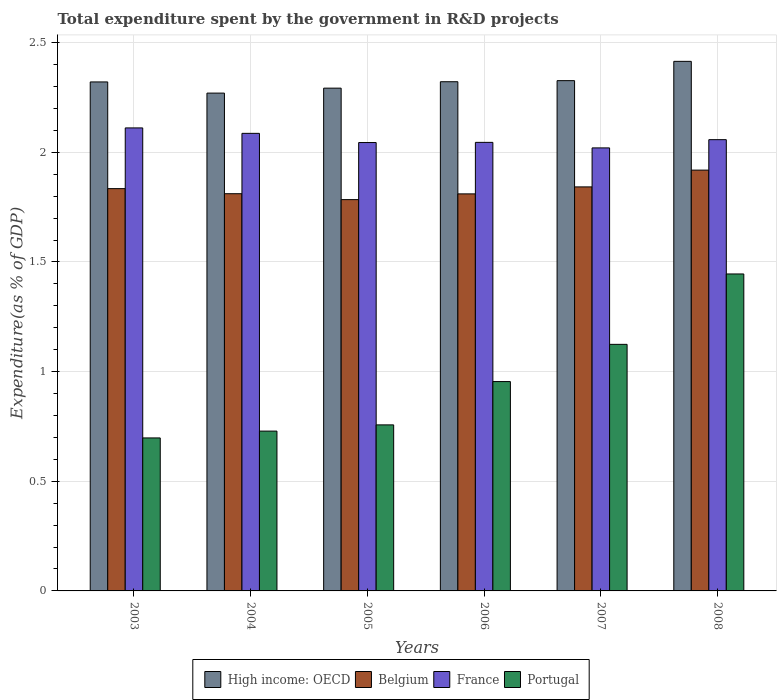How many groups of bars are there?
Offer a very short reply. 6. In how many cases, is the number of bars for a given year not equal to the number of legend labels?
Your answer should be very brief. 0. What is the total expenditure spent by the government in R&D projects in High income: OECD in 2008?
Provide a short and direct response. 2.41. Across all years, what is the maximum total expenditure spent by the government in R&D projects in France?
Your answer should be compact. 2.11. Across all years, what is the minimum total expenditure spent by the government in R&D projects in France?
Your answer should be compact. 2.02. In which year was the total expenditure spent by the government in R&D projects in Portugal minimum?
Offer a very short reply. 2003. What is the total total expenditure spent by the government in R&D projects in Portugal in the graph?
Give a very brief answer. 5.71. What is the difference between the total expenditure spent by the government in R&D projects in Belgium in 2004 and that in 2008?
Provide a succinct answer. -0.11. What is the difference between the total expenditure spent by the government in R&D projects in High income: OECD in 2005 and the total expenditure spent by the government in R&D projects in Belgium in 2003?
Offer a very short reply. 0.46. What is the average total expenditure spent by the government in R&D projects in France per year?
Your answer should be very brief. 2.06. In the year 2003, what is the difference between the total expenditure spent by the government in R&D projects in High income: OECD and total expenditure spent by the government in R&D projects in Belgium?
Keep it short and to the point. 0.49. What is the ratio of the total expenditure spent by the government in R&D projects in France in 2006 to that in 2007?
Keep it short and to the point. 1.01. What is the difference between the highest and the second highest total expenditure spent by the government in R&D projects in France?
Provide a short and direct response. 0.02. What is the difference between the highest and the lowest total expenditure spent by the government in R&D projects in High income: OECD?
Provide a short and direct response. 0.14. Is the sum of the total expenditure spent by the government in R&D projects in Portugal in 2006 and 2008 greater than the maximum total expenditure spent by the government in R&D projects in High income: OECD across all years?
Your answer should be compact. No. What does the 4th bar from the right in 2004 represents?
Keep it short and to the point. High income: OECD. Is it the case that in every year, the sum of the total expenditure spent by the government in R&D projects in France and total expenditure spent by the government in R&D projects in Portugal is greater than the total expenditure spent by the government in R&D projects in High income: OECD?
Provide a succinct answer. Yes. Are all the bars in the graph horizontal?
Ensure brevity in your answer.  No. How many years are there in the graph?
Offer a terse response. 6. Are the values on the major ticks of Y-axis written in scientific E-notation?
Make the answer very short. No. Does the graph contain any zero values?
Keep it short and to the point. No. Does the graph contain grids?
Your answer should be very brief. Yes. How are the legend labels stacked?
Your response must be concise. Horizontal. What is the title of the graph?
Offer a very short reply. Total expenditure spent by the government in R&D projects. What is the label or title of the X-axis?
Your response must be concise. Years. What is the label or title of the Y-axis?
Offer a very short reply. Expenditure(as % of GDP). What is the Expenditure(as % of GDP) in High income: OECD in 2003?
Your response must be concise. 2.32. What is the Expenditure(as % of GDP) in Belgium in 2003?
Make the answer very short. 1.83. What is the Expenditure(as % of GDP) in France in 2003?
Provide a short and direct response. 2.11. What is the Expenditure(as % of GDP) of Portugal in 2003?
Ensure brevity in your answer.  0.7. What is the Expenditure(as % of GDP) in High income: OECD in 2004?
Your answer should be very brief. 2.27. What is the Expenditure(as % of GDP) in Belgium in 2004?
Give a very brief answer. 1.81. What is the Expenditure(as % of GDP) in France in 2004?
Provide a succinct answer. 2.09. What is the Expenditure(as % of GDP) of Portugal in 2004?
Your answer should be compact. 0.73. What is the Expenditure(as % of GDP) of High income: OECD in 2005?
Your response must be concise. 2.29. What is the Expenditure(as % of GDP) of Belgium in 2005?
Provide a short and direct response. 1.78. What is the Expenditure(as % of GDP) in France in 2005?
Your response must be concise. 2.04. What is the Expenditure(as % of GDP) of Portugal in 2005?
Your answer should be compact. 0.76. What is the Expenditure(as % of GDP) in High income: OECD in 2006?
Your answer should be very brief. 2.32. What is the Expenditure(as % of GDP) of Belgium in 2006?
Your response must be concise. 1.81. What is the Expenditure(as % of GDP) of France in 2006?
Offer a terse response. 2.05. What is the Expenditure(as % of GDP) of Portugal in 2006?
Offer a terse response. 0.95. What is the Expenditure(as % of GDP) of High income: OECD in 2007?
Give a very brief answer. 2.33. What is the Expenditure(as % of GDP) of Belgium in 2007?
Offer a terse response. 1.84. What is the Expenditure(as % of GDP) of France in 2007?
Your answer should be compact. 2.02. What is the Expenditure(as % of GDP) of Portugal in 2007?
Your response must be concise. 1.12. What is the Expenditure(as % of GDP) in High income: OECD in 2008?
Provide a succinct answer. 2.41. What is the Expenditure(as % of GDP) in Belgium in 2008?
Offer a very short reply. 1.92. What is the Expenditure(as % of GDP) of France in 2008?
Offer a very short reply. 2.06. What is the Expenditure(as % of GDP) in Portugal in 2008?
Your response must be concise. 1.45. Across all years, what is the maximum Expenditure(as % of GDP) in High income: OECD?
Ensure brevity in your answer.  2.41. Across all years, what is the maximum Expenditure(as % of GDP) of Belgium?
Provide a succinct answer. 1.92. Across all years, what is the maximum Expenditure(as % of GDP) in France?
Make the answer very short. 2.11. Across all years, what is the maximum Expenditure(as % of GDP) of Portugal?
Provide a succinct answer. 1.45. Across all years, what is the minimum Expenditure(as % of GDP) of High income: OECD?
Make the answer very short. 2.27. Across all years, what is the minimum Expenditure(as % of GDP) of Belgium?
Ensure brevity in your answer.  1.78. Across all years, what is the minimum Expenditure(as % of GDP) of France?
Your answer should be compact. 2.02. Across all years, what is the minimum Expenditure(as % of GDP) of Portugal?
Provide a short and direct response. 0.7. What is the total Expenditure(as % of GDP) in High income: OECD in the graph?
Ensure brevity in your answer.  13.95. What is the total Expenditure(as % of GDP) in Belgium in the graph?
Your response must be concise. 11. What is the total Expenditure(as % of GDP) of France in the graph?
Provide a short and direct response. 12.36. What is the total Expenditure(as % of GDP) of Portugal in the graph?
Offer a very short reply. 5.71. What is the difference between the Expenditure(as % of GDP) in High income: OECD in 2003 and that in 2004?
Offer a very short reply. 0.05. What is the difference between the Expenditure(as % of GDP) of Belgium in 2003 and that in 2004?
Your response must be concise. 0.02. What is the difference between the Expenditure(as % of GDP) of France in 2003 and that in 2004?
Provide a succinct answer. 0.02. What is the difference between the Expenditure(as % of GDP) in Portugal in 2003 and that in 2004?
Offer a terse response. -0.03. What is the difference between the Expenditure(as % of GDP) in High income: OECD in 2003 and that in 2005?
Your response must be concise. 0.03. What is the difference between the Expenditure(as % of GDP) in Belgium in 2003 and that in 2005?
Make the answer very short. 0.05. What is the difference between the Expenditure(as % of GDP) in France in 2003 and that in 2005?
Make the answer very short. 0.07. What is the difference between the Expenditure(as % of GDP) of Portugal in 2003 and that in 2005?
Your answer should be compact. -0.06. What is the difference between the Expenditure(as % of GDP) in High income: OECD in 2003 and that in 2006?
Provide a short and direct response. -0. What is the difference between the Expenditure(as % of GDP) of Belgium in 2003 and that in 2006?
Give a very brief answer. 0.02. What is the difference between the Expenditure(as % of GDP) in France in 2003 and that in 2006?
Ensure brevity in your answer.  0.07. What is the difference between the Expenditure(as % of GDP) in Portugal in 2003 and that in 2006?
Offer a very short reply. -0.26. What is the difference between the Expenditure(as % of GDP) of High income: OECD in 2003 and that in 2007?
Provide a short and direct response. -0.01. What is the difference between the Expenditure(as % of GDP) in Belgium in 2003 and that in 2007?
Provide a succinct answer. -0.01. What is the difference between the Expenditure(as % of GDP) of France in 2003 and that in 2007?
Your answer should be compact. 0.09. What is the difference between the Expenditure(as % of GDP) in Portugal in 2003 and that in 2007?
Your answer should be compact. -0.43. What is the difference between the Expenditure(as % of GDP) in High income: OECD in 2003 and that in 2008?
Your answer should be very brief. -0.09. What is the difference between the Expenditure(as % of GDP) in Belgium in 2003 and that in 2008?
Your response must be concise. -0.08. What is the difference between the Expenditure(as % of GDP) of France in 2003 and that in 2008?
Provide a short and direct response. 0.05. What is the difference between the Expenditure(as % of GDP) in Portugal in 2003 and that in 2008?
Your answer should be very brief. -0.75. What is the difference between the Expenditure(as % of GDP) of High income: OECD in 2004 and that in 2005?
Provide a succinct answer. -0.02. What is the difference between the Expenditure(as % of GDP) in Belgium in 2004 and that in 2005?
Your response must be concise. 0.03. What is the difference between the Expenditure(as % of GDP) of France in 2004 and that in 2005?
Make the answer very short. 0.04. What is the difference between the Expenditure(as % of GDP) in Portugal in 2004 and that in 2005?
Your answer should be compact. -0.03. What is the difference between the Expenditure(as % of GDP) of High income: OECD in 2004 and that in 2006?
Make the answer very short. -0.05. What is the difference between the Expenditure(as % of GDP) in Belgium in 2004 and that in 2006?
Give a very brief answer. 0. What is the difference between the Expenditure(as % of GDP) in France in 2004 and that in 2006?
Your answer should be very brief. 0.04. What is the difference between the Expenditure(as % of GDP) in Portugal in 2004 and that in 2006?
Your answer should be very brief. -0.23. What is the difference between the Expenditure(as % of GDP) in High income: OECD in 2004 and that in 2007?
Your answer should be compact. -0.06. What is the difference between the Expenditure(as % of GDP) of Belgium in 2004 and that in 2007?
Make the answer very short. -0.03. What is the difference between the Expenditure(as % of GDP) of France in 2004 and that in 2007?
Offer a terse response. 0.07. What is the difference between the Expenditure(as % of GDP) of Portugal in 2004 and that in 2007?
Offer a very short reply. -0.4. What is the difference between the Expenditure(as % of GDP) of High income: OECD in 2004 and that in 2008?
Keep it short and to the point. -0.14. What is the difference between the Expenditure(as % of GDP) in Belgium in 2004 and that in 2008?
Your response must be concise. -0.11. What is the difference between the Expenditure(as % of GDP) in France in 2004 and that in 2008?
Your answer should be very brief. 0.03. What is the difference between the Expenditure(as % of GDP) of Portugal in 2004 and that in 2008?
Make the answer very short. -0.72. What is the difference between the Expenditure(as % of GDP) in High income: OECD in 2005 and that in 2006?
Keep it short and to the point. -0.03. What is the difference between the Expenditure(as % of GDP) in Belgium in 2005 and that in 2006?
Provide a succinct answer. -0.03. What is the difference between the Expenditure(as % of GDP) in France in 2005 and that in 2006?
Your response must be concise. -0. What is the difference between the Expenditure(as % of GDP) of Portugal in 2005 and that in 2006?
Your answer should be very brief. -0.2. What is the difference between the Expenditure(as % of GDP) in High income: OECD in 2005 and that in 2007?
Your response must be concise. -0.03. What is the difference between the Expenditure(as % of GDP) of Belgium in 2005 and that in 2007?
Keep it short and to the point. -0.06. What is the difference between the Expenditure(as % of GDP) in France in 2005 and that in 2007?
Your answer should be compact. 0.02. What is the difference between the Expenditure(as % of GDP) in Portugal in 2005 and that in 2007?
Your response must be concise. -0.37. What is the difference between the Expenditure(as % of GDP) of High income: OECD in 2005 and that in 2008?
Keep it short and to the point. -0.12. What is the difference between the Expenditure(as % of GDP) in Belgium in 2005 and that in 2008?
Make the answer very short. -0.13. What is the difference between the Expenditure(as % of GDP) of France in 2005 and that in 2008?
Your response must be concise. -0.01. What is the difference between the Expenditure(as % of GDP) in Portugal in 2005 and that in 2008?
Give a very brief answer. -0.69. What is the difference between the Expenditure(as % of GDP) in High income: OECD in 2006 and that in 2007?
Your answer should be compact. -0. What is the difference between the Expenditure(as % of GDP) of Belgium in 2006 and that in 2007?
Provide a short and direct response. -0.03. What is the difference between the Expenditure(as % of GDP) of France in 2006 and that in 2007?
Ensure brevity in your answer.  0.03. What is the difference between the Expenditure(as % of GDP) in Portugal in 2006 and that in 2007?
Ensure brevity in your answer.  -0.17. What is the difference between the Expenditure(as % of GDP) of High income: OECD in 2006 and that in 2008?
Provide a short and direct response. -0.09. What is the difference between the Expenditure(as % of GDP) in Belgium in 2006 and that in 2008?
Your answer should be compact. -0.11. What is the difference between the Expenditure(as % of GDP) of France in 2006 and that in 2008?
Offer a terse response. -0.01. What is the difference between the Expenditure(as % of GDP) of Portugal in 2006 and that in 2008?
Make the answer very short. -0.49. What is the difference between the Expenditure(as % of GDP) of High income: OECD in 2007 and that in 2008?
Give a very brief answer. -0.09. What is the difference between the Expenditure(as % of GDP) of Belgium in 2007 and that in 2008?
Your answer should be compact. -0.08. What is the difference between the Expenditure(as % of GDP) of France in 2007 and that in 2008?
Ensure brevity in your answer.  -0.04. What is the difference between the Expenditure(as % of GDP) in Portugal in 2007 and that in 2008?
Offer a terse response. -0.32. What is the difference between the Expenditure(as % of GDP) of High income: OECD in 2003 and the Expenditure(as % of GDP) of Belgium in 2004?
Your answer should be compact. 0.51. What is the difference between the Expenditure(as % of GDP) of High income: OECD in 2003 and the Expenditure(as % of GDP) of France in 2004?
Ensure brevity in your answer.  0.23. What is the difference between the Expenditure(as % of GDP) of High income: OECD in 2003 and the Expenditure(as % of GDP) of Portugal in 2004?
Keep it short and to the point. 1.59. What is the difference between the Expenditure(as % of GDP) in Belgium in 2003 and the Expenditure(as % of GDP) in France in 2004?
Provide a short and direct response. -0.25. What is the difference between the Expenditure(as % of GDP) of Belgium in 2003 and the Expenditure(as % of GDP) of Portugal in 2004?
Keep it short and to the point. 1.11. What is the difference between the Expenditure(as % of GDP) in France in 2003 and the Expenditure(as % of GDP) in Portugal in 2004?
Keep it short and to the point. 1.38. What is the difference between the Expenditure(as % of GDP) in High income: OECD in 2003 and the Expenditure(as % of GDP) in Belgium in 2005?
Make the answer very short. 0.54. What is the difference between the Expenditure(as % of GDP) in High income: OECD in 2003 and the Expenditure(as % of GDP) in France in 2005?
Your response must be concise. 0.28. What is the difference between the Expenditure(as % of GDP) in High income: OECD in 2003 and the Expenditure(as % of GDP) in Portugal in 2005?
Offer a terse response. 1.56. What is the difference between the Expenditure(as % of GDP) of Belgium in 2003 and the Expenditure(as % of GDP) of France in 2005?
Give a very brief answer. -0.21. What is the difference between the Expenditure(as % of GDP) in Belgium in 2003 and the Expenditure(as % of GDP) in Portugal in 2005?
Provide a succinct answer. 1.08. What is the difference between the Expenditure(as % of GDP) in France in 2003 and the Expenditure(as % of GDP) in Portugal in 2005?
Ensure brevity in your answer.  1.35. What is the difference between the Expenditure(as % of GDP) of High income: OECD in 2003 and the Expenditure(as % of GDP) of Belgium in 2006?
Provide a short and direct response. 0.51. What is the difference between the Expenditure(as % of GDP) of High income: OECD in 2003 and the Expenditure(as % of GDP) of France in 2006?
Offer a very short reply. 0.28. What is the difference between the Expenditure(as % of GDP) of High income: OECD in 2003 and the Expenditure(as % of GDP) of Portugal in 2006?
Offer a very short reply. 1.37. What is the difference between the Expenditure(as % of GDP) of Belgium in 2003 and the Expenditure(as % of GDP) of France in 2006?
Your answer should be very brief. -0.21. What is the difference between the Expenditure(as % of GDP) in Belgium in 2003 and the Expenditure(as % of GDP) in Portugal in 2006?
Make the answer very short. 0.88. What is the difference between the Expenditure(as % of GDP) in France in 2003 and the Expenditure(as % of GDP) in Portugal in 2006?
Provide a short and direct response. 1.16. What is the difference between the Expenditure(as % of GDP) of High income: OECD in 2003 and the Expenditure(as % of GDP) of Belgium in 2007?
Provide a succinct answer. 0.48. What is the difference between the Expenditure(as % of GDP) in High income: OECD in 2003 and the Expenditure(as % of GDP) in France in 2007?
Keep it short and to the point. 0.3. What is the difference between the Expenditure(as % of GDP) in High income: OECD in 2003 and the Expenditure(as % of GDP) in Portugal in 2007?
Offer a terse response. 1.2. What is the difference between the Expenditure(as % of GDP) of Belgium in 2003 and the Expenditure(as % of GDP) of France in 2007?
Offer a terse response. -0.19. What is the difference between the Expenditure(as % of GDP) in Belgium in 2003 and the Expenditure(as % of GDP) in Portugal in 2007?
Your answer should be compact. 0.71. What is the difference between the Expenditure(as % of GDP) in France in 2003 and the Expenditure(as % of GDP) in Portugal in 2007?
Your answer should be compact. 0.99. What is the difference between the Expenditure(as % of GDP) of High income: OECD in 2003 and the Expenditure(as % of GDP) of Belgium in 2008?
Your answer should be compact. 0.4. What is the difference between the Expenditure(as % of GDP) of High income: OECD in 2003 and the Expenditure(as % of GDP) of France in 2008?
Offer a terse response. 0.26. What is the difference between the Expenditure(as % of GDP) of High income: OECD in 2003 and the Expenditure(as % of GDP) of Portugal in 2008?
Your answer should be very brief. 0.88. What is the difference between the Expenditure(as % of GDP) of Belgium in 2003 and the Expenditure(as % of GDP) of France in 2008?
Your response must be concise. -0.22. What is the difference between the Expenditure(as % of GDP) of Belgium in 2003 and the Expenditure(as % of GDP) of Portugal in 2008?
Ensure brevity in your answer.  0.39. What is the difference between the Expenditure(as % of GDP) in France in 2003 and the Expenditure(as % of GDP) in Portugal in 2008?
Give a very brief answer. 0.67. What is the difference between the Expenditure(as % of GDP) in High income: OECD in 2004 and the Expenditure(as % of GDP) in Belgium in 2005?
Make the answer very short. 0.49. What is the difference between the Expenditure(as % of GDP) in High income: OECD in 2004 and the Expenditure(as % of GDP) in France in 2005?
Your answer should be very brief. 0.23. What is the difference between the Expenditure(as % of GDP) of High income: OECD in 2004 and the Expenditure(as % of GDP) of Portugal in 2005?
Give a very brief answer. 1.51. What is the difference between the Expenditure(as % of GDP) of Belgium in 2004 and the Expenditure(as % of GDP) of France in 2005?
Provide a short and direct response. -0.23. What is the difference between the Expenditure(as % of GDP) of Belgium in 2004 and the Expenditure(as % of GDP) of Portugal in 2005?
Ensure brevity in your answer.  1.05. What is the difference between the Expenditure(as % of GDP) in France in 2004 and the Expenditure(as % of GDP) in Portugal in 2005?
Offer a terse response. 1.33. What is the difference between the Expenditure(as % of GDP) of High income: OECD in 2004 and the Expenditure(as % of GDP) of Belgium in 2006?
Provide a short and direct response. 0.46. What is the difference between the Expenditure(as % of GDP) in High income: OECD in 2004 and the Expenditure(as % of GDP) in France in 2006?
Keep it short and to the point. 0.22. What is the difference between the Expenditure(as % of GDP) of High income: OECD in 2004 and the Expenditure(as % of GDP) of Portugal in 2006?
Offer a very short reply. 1.32. What is the difference between the Expenditure(as % of GDP) in Belgium in 2004 and the Expenditure(as % of GDP) in France in 2006?
Your answer should be very brief. -0.23. What is the difference between the Expenditure(as % of GDP) in Belgium in 2004 and the Expenditure(as % of GDP) in Portugal in 2006?
Provide a succinct answer. 0.86. What is the difference between the Expenditure(as % of GDP) in France in 2004 and the Expenditure(as % of GDP) in Portugal in 2006?
Offer a very short reply. 1.13. What is the difference between the Expenditure(as % of GDP) of High income: OECD in 2004 and the Expenditure(as % of GDP) of Belgium in 2007?
Ensure brevity in your answer.  0.43. What is the difference between the Expenditure(as % of GDP) of High income: OECD in 2004 and the Expenditure(as % of GDP) of France in 2007?
Make the answer very short. 0.25. What is the difference between the Expenditure(as % of GDP) in High income: OECD in 2004 and the Expenditure(as % of GDP) in Portugal in 2007?
Provide a succinct answer. 1.15. What is the difference between the Expenditure(as % of GDP) in Belgium in 2004 and the Expenditure(as % of GDP) in France in 2007?
Give a very brief answer. -0.21. What is the difference between the Expenditure(as % of GDP) in Belgium in 2004 and the Expenditure(as % of GDP) in Portugal in 2007?
Give a very brief answer. 0.69. What is the difference between the Expenditure(as % of GDP) of France in 2004 and the Expenditure(as % of GDP) of Portugal in 2007?
Provide a succinct answer. 0.96. What is the difference between the Expenditure(as % of GDP) in High income: OECD in 2004 and the Expenditure(as % of GDP) in Belgium in 2008?
Provide a succinct answer. 0.35. What is the difference between the Expenditure(as % of GDP) in High income: OECD in 2004 and the Expenditure(as % of GDP) in France in 2008?
Make the answer very short. 0.21. What is the difference between the Expenditure(as % of GDP) in High income: OECD in 2004 and the Expenditure(as % of GDP) in Portugal in 2008?
Provide a short and direct response. 0.82. What is the difference between the Expenditure(as % of GDP) in Belgium in 2004 and the Expenditure(as % of GDP) in France in 2008?
Your answer should be compact. -0.25. What is the difference between the Expenditure(as % of GDP) in Belgium in 2004 and the Expenditure(as % of GDP) in Portugal in 2008?
Keep it short and to the point. 0.37. What is the difference between the Expenditure(as % of GDP) in France in 2004 and the Expenditure(as % of GDP) in Portugal in 2008?
Offer a terse response. 0.64. What is the difference between the Expenditure(as % of GDP) in High income: OECD in 2005 and the Expenditure(as % of GDP) in Belgium in 2006?
Keep it short and to the point. 0.48. What is the difference between the Expenditure(as % of GDP) of High income: OECD in 2005 and the Expenditure(as % of GDP) of France in 2006?
Ensure brevity in your answer.  0.25. What is the difference between the Expenditure(as % of GDP) in High income: OECD in 2005 and the Expenditure(as % of GDP) in Portugal in 2006?
Provide a succinct answer. 1.34. What is the difference between the Expenditure(as % of GDP) in Belgium in 2005 and the Expenditure(as % of GDP) in France in 2006?
Your answer should be compact. -0.26. What is the difference between the Expenditure(as % of GDP) of Belgium in 2005 and the Expenditure(as % of GDP) of Portugal in 2006?
Ensure brevity in your answer.  0.83. What is the difference between the Expenditure(as % of GDP) in France in 2005 and the Expenditure(as % of GDP) in Portugal in 2006?
Make the answer very short. 1.09. What is the difference between the Expenditure(as % of GDP) in High income: OECD in 2005 and the Expenditure(as % of GDP) in Belgium in 2007?
Ensure brevity in your answer.  0.45. What is the difference between the Expenditure(as % of GDP) of High income: OECD in 2005 and the Expenditure(as % of GDP) of France in 2007?
Make the answer very short. 0.27. What is the difference between the Expenditure(as % of GDP) of High income: OECD in 2005 and the Expenditure(as % of GDP) of Portugal in 2007?
Provide a succinct answer. 1.17. What is the difference between the Expenditure(as % of GDP) in Belgium in 2005 and the Expenditure(as % of GDP) in France in 2007?
Provide a short and direct response. -0.24. What is the difference between the Expenditure(as % of GDP) in Belgium in 2005 and the Expenditure(as % of GDP) in Portugal in 2007?
Your answer should be compact. 0.66. What is the difference between the Expenditure(as % of GDP) of France in 2005 and the Expenditure(as % of GDP) of Portugal in 2007?
Offer a very short reply. 0.92. What is the difference between the Expenditure(as % of GDP) of High income: OECD in 2005 and the Expenditure(as % of GDP) of Belgium in 2008?
Offer a very short reply. 0.37. What is the difference between the Expenditure(as % of GDP) of High income: OECD in 2005 and the Expenditure(as % of GDP) of France in 2008?
Offer a very short reply. 0.23. What is the difference between the Expenditure(as % of GDP) of High income: OECD in 2005 and the Expenditure(as % of GDP) of Portugal in 2008?
Provide a short and direct response. 0.85. What is the difference between the Expenditure(as % of GDP) in Belgium in 2005 and the Expenditure(as % of GDP) in France in 2008?
Ensure brevity in your answer.  -0.27. What is the difference between the Expenditure(as % of GDP) of Belgium in 2005 and the Expenditure(as % of GDP) of Portugal in 2008?
Keep it short and to the point. 0.34. What is the difference between the Expenditure(as % of GDP) in France in 2005 and the Expenditure(as % of GDP) in Portugal in 2008?
Your answer should be very brief. 0.6. What is the difference between the Expenditure(as % of GDP) in High income: OECD in 2006 and the Expenditure(as % of GDP) in Belgium in 2007?
Provide a short and direct response. 0.48. What is the difference between the Expenditure(as % of GDP) of High income: OECD in 2006 and the Expenditure(as % of GDP) of France in 2007?
Make the answer very short. 0.3. What is the difference between the Expenditure(as % of GDP) of High income: OECD in 2006 and the Expenditure(as % of GDP) of Portugal in 2007?
Your answer should be very brief. 1.2. What is the difference between the Expenditure(as % of GDP) of Belgium in 2006 and the Expenditure(as % of GDP) of France in 2007?
Offer a very short reply. -0.21. What is the difference between the Expenditure(as % of GDP) in Belgium in 2006 and the Expenditure(as % of GDP) in Portugal in 2007?
Make the answer very short. 0.69. What is the difference between the Expenditure(as % of GDP) in France in 2006 and the Expenditure(as % of GDP) in Portugal in 2007?
Offer a very short reply. 0.92. What is the difference between the Expenditure(as % of GDP) in High income: OECD in 2006 and the Expenditure(as % of GDP) in Belgium in 2008?
Make the answer very short. 0.4. What is the difference between the Expenditure(as % of GDP) in High income: OECD in 2006 and the Expenditure(as % of GDP) in France in 2008?
Ensure brevity in your answer.  0.26. What is the difference between the Expenditure(as % of GDP) of High income: OECD in 2006 and the Expenditure(as % of GDP) of Portugal in 2008?
Give a very brief answer. 0.88. What is the difference between the Expenditure(as % of GDP) in Belgium in 2006 and the Expenditure(as % of GDP) in France in 2008?
Your answer should be compact. -0.25. What is the difference between the Expenditure(as % of GDP) of Belgium in 2006 and the Expenditure(as % of GDP) of Portugal in 2008?
Give a very brief answer. 0.37. What is the difference between the Expenditure(as % of GDP) in France in 2006 and the Expenditure(as % of GDP) in Portugal in 2008?
Make the answer very short. 0.6. What is the difference between the Expenditure(as % of GDP) in High income: OECD in 2007 and the Expenditure(as % of GDP) in Belgium in 2008?
Ensure brevity in your answer.  0.41. What is the difference between the Expenditure(as % of GDP) in High income: OECD in 2007 and the Expenditure(as % of GDP) in France in 2008?
Offer a very short reply. 0.27. What is the difference between the Expenditure(as % of GDP) of High income: OECD in 2007 and the Expenditure(as % of GDP) of Portugal in 2008?
Your answer should be compact. 0.88. What is the difference between the Expenditure(as % of GDP) of Belgium in 2007 and the Expenditure(as % of GDP) of France in 2008?
Provide a short and direct response. -0.22. What is the difference between the Expenditure(as % of GDP) in Belgium in 2007 and the Expenditure(as % of GDP) in Portugal in 2008?
Keep it short and to the point. 0.4. What is the difference between the Expenditure(as % of GDP) of France in 2007 and the Expenditure(as % of GDP) of Portugal in 2008?
Make the answer very short. 0.57. What is the average Expenditure(as % of GDP) of High income: OECD per year?
Make the answer very short. 2.32. What is the average Expenditure(as % of GDP) of Belgium per year?
Your answer should be very brief. 1.83. What is the average Expenditure(as % of GDP) of France per year?
Your response must be concise. 2.06. What is the average Expenditure(as % of GDP) of Portugal per year?
Offer a terse response. 0.95. In the year 2003, what is the difference between the Expenditure(as % of GDP) in High income: OECD and Expenditure(as % of GDP) in Belgium?
Ensure brevity in your answer.  0.49. In the year 2003, what is the difference between the Expenditure(as % of GDP) of High income: OECD and Expenditure(as % of GDP) of France?
Ensure brevity in your answer.  0.21. In the year 2003, what is the difference between the Expenditure(as % of GDP) in High income: OECD and Expenditure(as % of GDP) in Portugal?
Offer a terse response. 1.62. In the year 2003, what is the difference between the Expenditure(as % of GDP) of Belgium and Expenditure(as % of GDP) of France?
Offer a very short reply. -0.28. In the year 2003, what is the difference between the Expenditure(as % of GDP) of Belgium and Expenditure(as % of GDP) of Portugal?
Your answer should be compact. 1.14. In the year 2003, what is the difference between the Expenditure(as % of GDP) in France and Expenditure(as % of GDP) in Portugal?
Offer a terse response. 1.41. In the year 2004, what is the difference between the Expenditure(as % of GDP) of High income: OECD and Expenditure(as % of GDP) of Belgium?
Provide a succinct answer. 0.46. In the year 2004, what is the difference between the Expenditure(as % of GDP) in High income: OECD and Expenditure(as % of GDP) in France?
Ensure brevity in your answer.  0.18. In the year 2004, what is the difference between the Expenditure(as % of GDP) in High income: OECD and Expenditure(as % of GDP) in Portugal?
Your answer should be compact. 1.54. In the year 2004, what is the difference between the Expenditure(as % of GDP) of Belgium and Expenditure(as % of GDP) of France?
Offer a very short reply. -0.28. In the year 2004, what is the difference between the Expenditure(as % of GDP) in Belgium and Expenditure(as % of GDP) in Portugal?
Offer a terse response. 1.08. In the year 2004, what is the difference between the Expenditure(as % of GDP) of France and Expenditure(as % of GDP) of Portugal?
Your response must be concise. 1.36. In the year 2005, what is the difference between the Expenditure(as % of GDP) of High income: OECD and Expenditure(as % of GDP) of Belgium?
Offer a terse response. 0.51. In the year 2005, what is the difference between the Expenditure(as % of GDP) in High income: OECD and Expenditure(as % of GDP) in France?
Ensure brevity in your answer.  0.25. In the year 2005, what is the difference between the Expenditure(as % of GDP) in High income: OECD and Expenditure(as % of GDP) in Portugal?
Offer a terse response. 1.54. In the year 2005, what is the difference between the Expenditure(as % of GDP) in Belgium and Expenditure(as % of GDP) in France?
Your answer should be compact. -0.26. In the year 2005, what is the difference between the Expenditure(as % of GDP) in Belgium and Expenditure(as % of GDP) in Portugal?
Keep it short and to the point. 1.03. In the year 2005, what is the difference between the Expenditure(as % of GDP) of France and Expenditure(as % of GDP) of Portugal?
Make the answer very short. 1.29. In the year 2006, what is the difference between the Expenditure(as % of GDP) of High income: OECD and Expenditure(as % of GDP) of Belgium?
Provide a succinct answer. 0.51. In the year 2006, what is the difference between the Expenditure(as % of GDP) of High income: OECD and Expenditure(as % of GDP) of France?
Provide a short and direct response. 0.28. In the year 2006, what is the difference between the Expenditure(as % of GDP) of High income: OECD and Expenditure(as % of GDP) of Portugal?
Provide a succinct answer. 1.37. In the year 2006, what is the difference between the Expenditure(as % of GDP) in Belgium and Expenditure(as % of GDP) in France?
Provide a short and direct response. -0.23. In the year 2006, what is the difference between the Expenditure(as % of GDP) in Belgium and Expenditure(as % of GDP) in Portugal?
Offer a very short reply. 0.86. In the year 2006, what is the difference between the Expenditure(as % of GDP) of France and Expenditure(as % of GDP) of Portugal?
Your answer should be very brief. 1.09. In the year 2007, what is the difference between the Expenditure(as % of GDP) in High income: OECD and Expenditure(as % of GDP) in Belgium?
Keep it short and to the point. 0.48. In the year 2007, what is the difference between the Expenditure(as % of GDP) of High income: OECD and Expenditure(as % of GDP) of France?
Your answer should be very brief. 0.31. In the year 2007, what is the difference between the Expenditure(as % of GDP) in High income: OECD and Expenditure(as % of GDP) in Portugal?
Offer a terse response. 1.2. In the year 2007, what is the difference between the Expenditure(as % of GDP) of Belgium and Expenditure(as % of GDP) of France?
Ensure brevity in your answer.  -0.18. In the year 2007, what is the difference between the Expenditure(as % of GDP) in Belgium and Expenditure(as % of GDP) in Portugal?
Keep it short and to the point. 0.72. In the year 2007, what is the difference between the Expenditure(as % of GDP) in France and Expenditure(as % of GDP) in Portugal?
Make the answer very short. 0.9. In the year 2008, what is the difference between the Expenditure(as % of GDP) in High income: OECD and Expenditure(as % of GDP) in Belgium?
Offer a terse response. 0.5. In the year 2008, what is the difference between the Expenditure(as % of GDP) in High income: OECD and Expenditure(as % of GDP) in France?
Ensure brevity in your answer.  0.36. In the year 2008, what is the difference between the Expenditure(as % of GDP) of High income: OECD and Expenditure(as % of GDP) of Portugal?
Offer a very short reply. 0.97. In the year 2008, what is the difference between the Expenditure(as % of GDP) in Belgium and Expenditure(as % of GDP) in France?
Keep it short and to the point. -0.14. In the year 2008, what is the difference between the Expenditure(as % of GDP) in Belgium and Expenditure(as % of GDP) in Portugal?
Your response must be concise. 0.47. In the year 2008, what is the difference between the Expenditure(as % of GDP) in France and Expenditure(as % of GDP) in Portugal?
Keep it short and to the point. 0.61. What is the ratio of the Expenditure(as % of GDP) in High income: OECD in 2003 to that in 2004?
Ensure brevity in your answer.  1.02. What is the ratio of the Expenditure(as % of GDP) of Belgium in 2003 to that in 2004?
Provide a short and direct response. 1.01. What is the ratio of the Expenditure(as % of GDP) in France in 2003 to that in 2004?
Your answer should be compact. 1.01. What is the ratio of the Expenditure(as % of GDP) in Portugal in 2003 to that in 2004?
Ensure brevity in your answer.  0.96. What is the ratio of the Expenditure(as % of GDP) in High income: OECD in 2003 to that in 2005?
Give a very brief answer. 1.01. What is the ratio of the Expenditure(as % of GDP) of Belgium in 2003 to that in 2005?
Ensure brevity in your answer.  1.03. What is the ratio of the Expenditure(as % of GDP) in France in 2003 to that in 2005?
Your answer should be compact. 1.03. What is the ratio of the Expenditure(as % of GDP) of Portugal in 2003 to that in 2005?
Your answer should be very brief. 0.92. What is the ratio of the Expenditure(as % of GDP) in High income: OECD in 2003 to that in 2006?
Your answer should be very brief. 1. What is the ratio of the Expenditure(as % of GDP) in Belgium in 2003 to that in 2006?
Keep it short and to the point. 1.01. What is the ratio of the Expenditure(as % of GDP) of France in 2003 to that in 2006?
Your answer should be very brief. 1.03. What is the ratio of the Expenditure(as % of GDP) in Portugal in 2003 to that in 2006?
Your response must be concise. 0.73. What is the ratio of the Expenditure(as % of GDP) in France in 2003 to that in 2007?
Make the answer very short. 1.05. What is the ratio of the Expenditure(as % of GDP) in Portugal in 2003 to that in 2007?
Your answer should be very brief. 0.62. What is the ratio of the Expenditure(as % of GDP) of High income: OECD in 2003 to that in 2008?
Give a very brief answer. 0.96. What is the ratio of the Expenditure(as % of GDP) of Belgium in 2003 to that in 2008?
Your answer should be very brief. 0.96. What is the ratio of the Expenditure(as % of GDP) in France in 2003 to that in 2008?
Your answer should be very brief. 1.03. What is the ratio of the Expenditure(as % of GDP) of Portugal in 2003 to that in 2008?
Give a very brief answer. 0.48. What is the ratio of the Expenditure(as % of GDP) of High income: OECD in 2004 to that in 2005?
Offer a terse response. 0.99. What is the ratio of the Expenditure(as % of GDP) of Belgium in 2004 to that in 2005?
Your answer should be very brief. 1.02. What is the ratio of the Expenditure(as % of GDP) of France in 2004 to that in 2005?
Provide a short and direct response. 1.02. What is the ratio of the Expenditure(as % of GDP) in Portugal in 2004 to that in 2005?
Your answer should be very brief. 0.96. What is the ratio of the Expenditure(as % of GDP) in High income: OECD in 2004 to that in 2006?
Your response must be concise. 0.98. What is the ratio of the Expenditure(as % of GDP) of France in 2004 to that in 2006?
Offer a very short reply. 1.02. What is the ratio of the Expenditure(as % of GDP) in Portugal in 2004 to that in 2006?
Offer a terse response. 0.76. What is the ratio of the Expenditure(as % of GDP) of High income: OECD in 2004 to that in 2007?
Provide a succinct answer. 0.98. What is the ratio of the Expenditure(as % of GDP) of Belgium in 2004 to that in 2007?
Your answer should be very brief. 0.98. What is the ratio of the Expenditure(as % of GDP) of France in 2004 to that in 2007?
Offer a very short reply. 1.03. What is the ratio of the Expenditure(as % of GDP) in Portugal in 2004 to that in 2007?
Make the answer very short. 0.65. What is the ratio of the Expenditure(as % of GDP) of High income: OECD in 2004 to that in 2008?
Ensure brevity in your answer.  0.94. What is the ratio of the Expenditure(as % of GDP) in Belgium in 2004 to that in 2008?
Provide a short and direct response. 0.94. What is the ratio of the Expenditure(as % of GDP) in Portugal in 2004 to that in 2008?
Offer a terse response. 0.5. What is the ratio of the Expenditure(as % of GDP) in High income: OECD in 2005 to that in 2006?
Provide a short and direct response. 0.99. What is the ratio of the Expenditure(as % of GDP) in Belgium in 2005 to that in 2006?
Keep it short and to the point. 0.99. What is the ratio of the Expenditure(as % of GDP) in Portugal in 2005 to that in 2006?
Offer a terse response. 0.79. What is the ratio of the Expenditure(as % of GDP) in Belgium in 2005 to that in 2007?
Your answer should be compact. 0.97. What is the ratio of the Expenditure(as % of GDP) in France in 2005 to that in 2007?
Offer a very short reply. 1.01. What is the ratio of the Expenditure(as % of GDP) of Portugal in 2005 to that in 2007?
Your response must be concise. 0.67. What is the ratio of the Expenditure(as % of GDP) of High income: OECD in 2005 to that in 2008?
Give a very brief answer. 0.95. What is the ratio of the Expenditure(as % of GDP) of Belgium in 2005 to that in 2008?
Offer a terse response. 0.93. What is the ratio of the Expenditure(as % of GDP) in Portugal in 2005 to that in 2008?
Your answer should be compact. 0.52. What is the ratio of the Expenditure(as % of GDP) of High income: OECD in 2006 to that in 2007?
Ensure brevity in your answer.  1. What is the ratio of the Expenditure(as % of GDP) of Belgium in 2006 to that in 2007?
Keep it short and to the point. 0.98. What is the ratio of the Expenditure(as % of GDP) of France in 2006 to that in 2007?
Make the answer very short. 1.01. What is the ratio of the Expenditure(as % of GDP) in Portugal in 2006 to that in 2007?
Keep it short and to the point. 0.85. What is the ratio of the Expenditure(as % of GDP) in High income: OECD in 2006 to that in 2008?
Your answer should be very brief. 0.96. What is the ratio of the Expenditure(as % of GDP) in Belgium in 2006 to that in 2008?
Your answer should be compact. 0.94. What is the ratio of the Expenditure(as % of GDP) in Portugal in 2006 to that in 2008?
Offer a very short reply. 0.66. What is the ratio of the Expenditure(as % of GDP) of High income: OECD in 2007 to that in 2008?
Ensure brevity in your answer.  0.96. What is the ratio of the Expenditure(as % of GDP) of Belgium in 2007 to that in 2008?
Keep it short and to the point. 0.96. What is the ratio of the Expenditure(as % of GDP) of France in 2007 to that in 2008?
Provide a short and direct response. 0.98. What is the ratio of the Expenditure(as % of GDP) in Portugal in 2007 to that in 2008?
Provide a short and direct response. 0.78. What is the difference between the highest and the second highest Expenditure(as % of GDP) in High income: OECD?
Provide a short and direct response. 0.09. What is the difference between the highest and the second highest Expenditure(as % of GDP) in Belgium?
Ensure brevity in your answer.  0.08. What is the difference between the highest and the second highest Expenditure(as % of GDP) in France?
Give a very brief answer. 0.02. What is the difference between the highest and the second highest Expenditure(as % of GDP) of Portugal?
Keep it short and to the point. 0.32. What is the difference between the highest and the lowest Expenditure(as % of GDP) of High income: OECD?
Your answer should be very brief. 0.14. What is the difference between the highest and the lowest Expenditure(as % of GDP) in Belgium?
Make the answer very short. 0.13. What is the difference between the highest and the lowest Expenditure(as % of GDP) in France?
Make the answer very short. 0.09. What is the difference between the highest and the lowest Expenditure(as % of GDP) in Portugal?
Give a very brief answer. 0.75. 